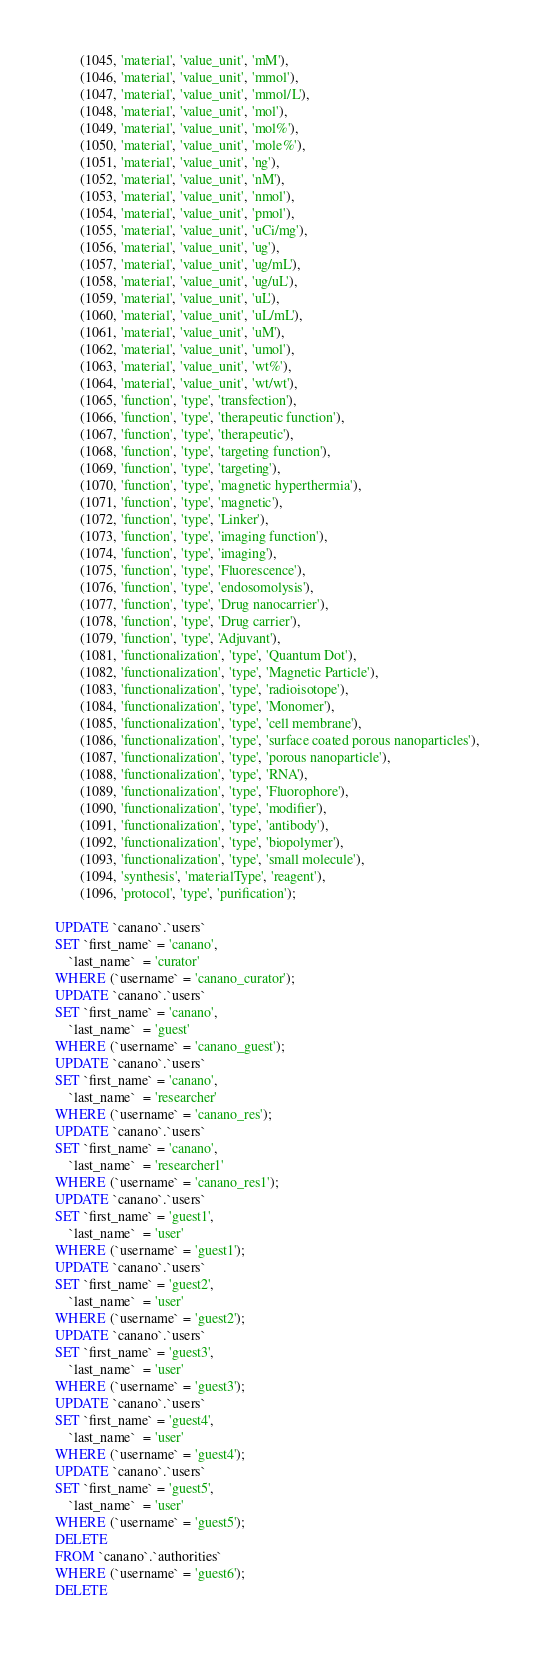<code> <loc_0><loc_0><loc_500><loc_500><_SQL_>       (1045, 'material', 'value_unit', 'mM'),
       (1046, 'material', 'value_unit', 'mmol'),
       (1047, 'material', 'value_unit', 'mmol/L'),
       (1048, 'material', 'value_unit', 'mol'),
       (1049, 'material', 'value_unit', 'mol%'),
       (1050, 'material', 'value_unit', 'mole%'),
       (1051, 'material', 'value_unit', 'ng'),
       (1052, 'material', 'value_unit', 'nM'),
       (1053, 'material', 'value_unit', 'nmol'),
       (1054, 'material', 'value_unit', 'pmol'),
       (1055, 'material', 'value_unit', 'uCi/mg'),
       (1056, 'material', 'value_unit', 'ug'),
       (1057, 'material', 'value_unit', 'ug/mL'),
       (1058, 'material', 'value_unit', 'ug/uL'),
       (1059, 'material', 'value_unit', 'uL'),
       (1060, 'material', 'value_unit', 'uL/mL'),
       (1061, 'material', 'value_unit', 'uM'),
       (1062, 'material', 'value_unit', 'umol'),
       (1063, 'material', 'value_unit', 'wt%'),
       (1064, 'material', 'value_unit', 'wt/wt'),
       (1065, 'function', 'type', 'transfection'),
       (1066, 'function', 'type', 'therapeutic function'),
       (1067, 'function', 'type', 'therapeutic'),
       (1068, 'function', 'type', 'targeting function'),
       (1069, 'function', 'type', 'targeting'),
       (1070, 'function', 'type', 'magnetic hyperthermia'),
       (1071, 'function', 'type', 'magnetic'),
       (1072, 'function', 'type', 'Linker'),
       (1073, 'function', 'type', 'imaging function'),
       (1074, 'function', 'type', 'imaging'),
       (1075, 'function', 'type', 'Fluorescence'),
       (1076, 'function', 'type', 'endosomolysis'),
       (1077, 'function', 'type', 'Drug nanocarrier'),
       (1078, 'function', 'type', 'Drug carrier'),
       (1079, 'function', 'type', 'Adjuvant'),
       (1081, 'functionalization', 'type', 'Quantum Dot'),
       (1082, 'functionalization', 'type', 'Magnetic Particle'),
       (1083, 'functionalization', 'type', 'radioisotope'),
       (1084, 'functionalization', 'type', 'Monomer'),
       (1085, 'functionalization', 'type', 'cell membrane'),
       (1086, 'functionalization', 'type', 'surface coated porous nanoparticles'),
       (1087, 'functionalization', 'type', 'porous nanoparticle'),
       (1088, 'functionalization', 'type', 'RNA'),
       (1089, 'functionalization', 'type', 'Fluorophore'),
       (1090, 'functionalization', 'type', 'modifier'),
       (1091, 'functionalization', 'type', 'antibody'),
       (1092, 'functionalization', 'type', 'biopolymer'),
       (1093, 'functionalization', 'type', 'small molecule'),
       (1094, 'synthesis', 'materialType', 'reagent'),
       (1096, 'protocol', 'type', 'purification');

UPDATE `canano`.`users`
SET `first_name` = 'canano',
    `last_name`  = 'curator'
WHERE (`username` = 'canano_curator');
UPDATE `canano`.`users`
SET `first_name` = 'canano',
    `last_name`  = 'guest'
WHERE (`username` = 'canano_guest');
UPDATE `canano`.`users`
SET `first_name` = 'canano',
    `last_name`  = 'researcher'
WHERE (`username` = 'canano_res');
UPDATE `canano`.`users`
SET `first_name` = 'canano',
    `last_name`  = 'researcher1'
WHERE (`username` = 'canano_res1');
UPDATE `canano`.`users`
SET `first_name` = 'guest1',
    `last_name`  = 'user'
WHERE (`username` = 'guest1');
UPDATE `canano`.`users`
SET `first_name` = 'guest2',
    `last_name`  = 'user'
WHERE (`username` = 'guest2');
UPDATE `canano`.`users`
SET `first_name` = 'guest3',
    `last_name`  = 'user'
WHERE (`username` = 'guest3');
UPDATE `canano`.`users`
SET `first_name` = 'guest4',
    `last_name`  = 'user'
WHERE (`username` = 'guest4');
UPDATE `canano`.`users`
SET `first_name` = 'guest5',
    `last_name`  = 'user'
WHERE (`username` = 'guest5');
DELETE
FROM `canano`.`authorities`
WHERE (`username` = 'guest6');
DELETE</code> 